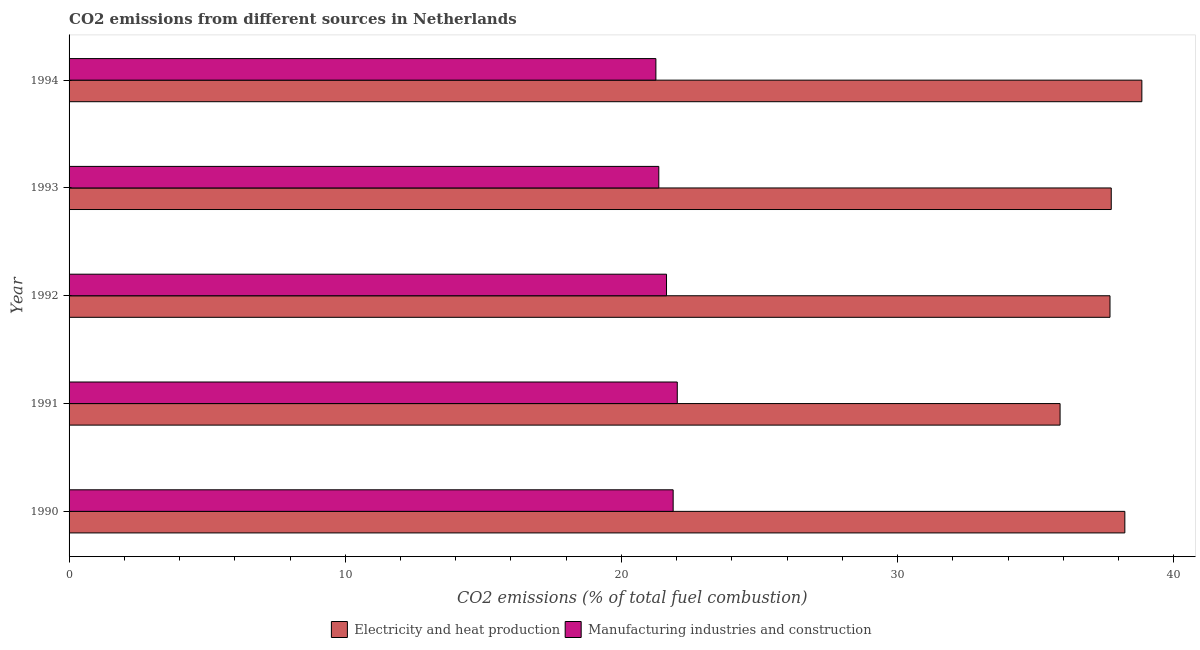How many different coloured bars are there?
Provide a short and direct response. 2. Are the number of bars on each tick of the Y-axis equal?
Give a very brief answer. Yes. What is the label of the 2nd group of bars from the top?
Offer a terse response. 1993. In how many cases, is the number of bars for a given year not equal to the number of legend labels?
Give a very brief answer. 0. What is the co2 emissions due to electricity and heat production in 1992?
Offer a terse response. 37.69. Across all years, what is the maximum co2 emissions due to electricity and heat production?
Make the answer very short. 38.84. Across all years, what is the minimum co2 emissions due to electricity and heat production?
Provide a short and direct response. 35.88. In which year was the co2 emissions due to electricity and heat production minimum?
Your answer should be compact. 1991. What is the total co2 emissions due to manufacturing industries in the graph?
Provide a succinct answer. 108.13. What is the difference between the co2 emissions due to manufacturing industries in 1992 and that in 1993?
Your answer should be very brief. 0.28. What is the difference between the co2 emissions due to manufacturing industries in 1990 and the co2 emissions due to electricity and heat production in 1993?
Your response must be concise. -15.86. What is the average co2 emissions due to electricity and heat production per year?
Provide a short and direct response. 37.68. In the year 1992, what is the difference between the co2 emissions due to manufacturing industries and co2 emissions due to electricity and heat production?
Provide a short and direct response. -16.06. In how many years, is the co2 emissions due to electricity and heat production greater than 36 %?
Your response must be concise. 4. What is the ratio of the co2 emissions due to electricity and heat production in 1990 to that in 1993?
Provide a succinct answer. 1.01. Is the co2 emissions due to electricity and heat production in 1990 less than that in 1992?
Offer a terse response. No. What is the difference between the highest and the second highest co2 emissions due to electricity and heat production?
Make the answer very short. 0.62. What is the difference between the highest and the lowest co2 emissions due to electricity and heat production?
Your answer should be very brief. 2.96. In how many years, is the co2 emissions due to electricity and heat production greater than the average co2 emissions due to electricity and heat production taken over all years?
Provide a short and direct response. 4. Is the sum of the co2 emissions due to manufacturing industries in 1990 and 1994 greater than the maximum co2 emissions due to electricity and heat production across all years?
Make the answer very short. Yes. What does the 2nd bar from the top in 1990 represents?
Make the answer very short. Electricity and heat production. What does the 2nd bar from the bottom in 1990 represents?
Your answer should be compact. Manufacturing industries and construction. How many bars are there?
Your response must be concise. 10. Where does the legend appear in the graph?
Ensure brevity in your answer.  Bottom center. How are the legend labels stacked?
Your response must be concise. Horizontal. What is the title of the graph?
Ensure brevity in your answer.  CO2 emissions from different sources in Netherlands. What is the label or title of the X-axis?
Your answer should be compact. CO2 emissions (% of total fuel combustion). What is the label or title of the Y-axis?
Offer a terse response. Year. What is the CO2 emissions (% of total fuel combustion) of Electricity and heat production in 1990?
Provide a short and direct response. 38.23. What is the CO2 emissions (% of total fuel combustion) in Manufacturing industries and construction in 1990?
Give a very brief answer. 21.87. What is the CO2 emissions (% of total fuel combustion) of Electricity and heat production in 1991?
Provide a succinct answer. 35.88. What is the CO2 emissions (% of total fuel combustion) of Manufacturing industries and construction in 1991?
Provide a succinct answer. 22.02. What is the CO2 emissions (% of total fuel combustion) of Electricity and heat production in 1992?
Provide a succinct answer. 37.69. What is the CO2 emissions (% of total fuel combustion) in Manufacturing industries and construction in 1992?
Provide a succinct answer. 21.63. What is the CO2 emissions (% of total fuel combustion) in Electricity and heat production in 1993?
Offer a very short reply. 37.74. What is the CO2 emissions (% of total fuel combustion) of Manufacturing industries and construction in 1993?
Keep it short and to the point. 21.35. What is the CO2 emissions (% of total fuel combustion) of Electricity and heat production in 1994?
Your answer should be compact. 38.84. What is the CO2 emissions (% of total fuel combustion) of Manufacturing industries and construction in 1994?
Give a very brief answer. 21.25. Across all years, what is the maximum CO2 emissions (% of total fuel combustion) of Electricity and heat production?
Your answer should be very brief. 38.84. Across all years, what is the maximum CO2 emissions (% of total fuel combustion) of Manufacturing industries and construction?
Your answer should be compact. 22.02. Across all years, what is the minimum CO2 emissions (% of total fuel combustion) of Electricity and heat production?
Provide a succinct answer. 35.88. Across all years, what is the minimum CO2 emissions (% of total fuel combustion) of Manufacturing industries and construction?
Make the answer very short. 21.25. What is the total CO2 emissions (% of total fuel combustion) of Electricity and heat production in the graph?
Offer a terse response. 188.39. What is the total CO2 emissions (% of total fuel combustion) in Manufacturing industries and construction in the graph?
Make the answer very short. 108.13. What is the difference between the CO2 emissions (% of total fuel combustion) in Electricity and heat production in 1990 and that in 1991?
Your response must be concise. 2.35. What is the difference between the CO2 emissions (% of total fuel combustion) of Manufacturing industries and construction in 1990 and that in 1991?
Your answer should be very brief. -0.15. What is the difference between the CO2 emissions (% of total fuel combustion) of Electricity and heat production in 1990 and that in 1992?
Your answer should be compact. 0.54. What is the difference between the CO2 emissions (% of total fuel combustion) in Manufacturing industries and construction in 1990 and that in 1992?
Give a very brief answer. 0.24. What is the difference between the CO2 emissions (% of total fuel combustion) of Electricity and heat production in 1990 and that in 1993?
Make the answer very short. 0.49. What is the difference between the CO2 emissions (% of total fuel combustion) in Manufacturing industries and construction in 1990 and that in 1993?
Give a very brief answer. 0.52. What is the difference between the CO2 emissions (% of total fuel combustion) of Electricity and heat production in 1990 and that in 1994?
Offer a very short reply. -0.62. What is the difference between the CO2 emissions (% of total fuel combustion) in Manufacturing industries and construction in 1990 and that in 1994?
Ensure brevity in your answer.  0.63. What is the difference between the CO2 emissions (% of total fuel combustion) in Electricity and heat production in 1991 and that in 1992?
Make the answer very short. -1.81. What is the difference between the CO2 emissions (% of total fuel combustion) of Manufacturing industries and construction in 1991 and that in 1992?
Your answer should be compact. 0.39. What is the difference between the CO2 emissions (% of total fuel combustion) of Electricity and heat production in 1991 and that in 1993?
Provide a short and direct response. -1.85. What is the difference between the CO2 emissions (% of total fuel combustion) in Manufacturing industries and construction in 1991 and that in 1993?
Your response must be concise. 0.67. What is the difference between the CO2 emissions (% of total fuel combustion) in Electricity and heat production in 1991 and that in 1994?
Give a very brief answer. -2.96. What is the difference between the CO2 emissions (% of total fuel combustion) of Manufacturing industries and construction in 1991 and that in 1994?
Make the answer very short. 0.77. What is the difference between the CO2 emissions (% of total fuel combustion) of Electricity and heat production in 1992 and that in 1993?
Your answer should be compact. -0.04. What is the difference between the CO2 emissions (% of total fuel combustion) in Manufacturing industries and construction in 1992 and that in 1993?
Offer a very short reply. 0.28. What is the difference between the CO2 emissions (% of total fuel combustion) of Electricity and heat production in 1992 and that in 1994?
Your answer should be compact. -1.15. What is the difference between the CO2 emissions (% of total fuel combustion) in Manufacturing industries and construction in 1992 and that in 1994?
Your answer should be compact. 0.39. What is the difference between the CO2 emissions (% of total fuel combustion) in Electricity and heat production in 1993 and that in 1994?
Make the answer very short. -1.11. What is the difference between the CO2 emissions (% of total fuel combustion) in Manufacturing industries and construction in 1993 and that in 1994?
Make the answer very short. 0.11. What is the difference between the CO2 emissions (% of total fuel combustion) of Electricity and heat production in 1990 and the CO2 emissions (% of total fuel combustion) of Manufacturing industries and construction in 1991?
Your answer should be very brief. 16.21. What is the difference between the CO2 emissions (% of total fuel combustion) of Electricity and heat production in 1990 and the CO2 emissions (% of total fuel combustion) of Manufacturing industries and construction in 1992?
Provide a succinct answer. 16.6. What is the difference between the CO2 emissions (% of total fuel combustion) in Electricity and heat production in 1990 and the CO2 emissions (% of total fuel combustion) in Manufacturing industries and construction in 1993?
Provide a short and direct response. 16.88. What is the difference between the CO2 emissions (% of total fuel combustion) of Electricity and heat production in 1990 and the CO2 emissions (% of total fuel combustion) of Manufacturing industries and construction in 1994?
Your answer should be compact. 16.98. What is the difference between the CO2 emissions (% of total fuel combustion) in Electricity and heat production in 1991 and the CO2 emissions (% of total fuel combustion) in Manufacturing industries and construction in 1992?
Keep it short and to the point. 14.25. What is the difference between the CO2 emissions (% of total fuel combustion) of Electricity and heat production in 1991 and the CO2 emissions (% of total fuel combustion) of Manufacturing industries and construction in 1993?
Keep it short and to the point. 14.53. What is the difference between the CO2 emissions (% of total fuel combustion) of Electricity and heat production in 1991 and the CO2 emissions (% of total fuel combustion) of Manufacturing industries and construction in 1994?
Provide a short and direct response. 14.64. What is the difference between the CO2 emissions (% of total fuel combustion) of Electricity and heat production in 1992 and the CO2 emissions (% of total fuel combustion) of Manufacturing industries and construction in 1993?
Ensure brevity in your answer.  16.34. What is the difference between the CO2 emissions (% of total fuel combustion) in Electricity and heat production in 1992 and the CO2 emissions (% of total fuel combustion) in Manufacturing industries and construction in 1994?
Ensure brevity in your answer.  16.44. What is the difference between the CO2 emissions (% of total fuel combustion) of Electricity and heat production in 1993 and the CO2 emissions (% of total fuel combustion) of Manufacturing industries and construction in 1994?
Offer a very short reply. 16.49. What is the average CO2 emissions (% of total fuel combustion) of Electricity and heat production per year?
Your answer should be very brief. 37.68. What is the average CO2 emissions (% of total fuel combustion) of Manufacturing industries and construction per year?
Your answer should be very brief. 21.63. In the year 1990, what is the difference between the CO2 emissions (% of total fuel combustion) in Electricity and heat production and CO2 emissions (% of total fuel combustion) in Manufacturing industries and construction?
Ensure brevity in your answer.  16.36. In the year 1991, what is the difference between the CO2 emissions (% of total fuel combustion) of Electricity and heat production and CO2 emissions (% of total fuel combustion) of Manufacturing industries and construction?
Offer a terse response. 13.86. In the year 1992, what is the difference between the CO2 emissions (% of total fuel combustion) of Electricity and heat production and CO2 emissions (% of total fuel combustion) of Manufacturing industries and construction?
Ensure brevity in your answer.  16.06. In the year 1993, what is the difference between the CO2 emissions (% of total fuel combustion) of Electricity and heat production and CO2 emissions (% of total fuel combustion) of Manufacturing industries and construction?
Give a very brief answer. 16.38. In the year 1994, what is the difference between the CO2 emissions (% of total fuel combustion) of Electricity and heat production and CO2 emissions (% of total fuel combustion) of Manufacturing industries and construction?
Offer a terse response. 17.6. What is the ratio of the CO2 emissions (% of total fuel combustion) in Electricity and heat production in 1990 to that in 1991?
Ensure brevity in your answer.  1.07. What is the ratio of the CO2 emissions (% of total fuel combustion) of Manufacturing industries and construction in 1990 to that in 1991?
Provide a short and direct response. 0.99. What is the ratio of the CO2 emissions (% of total fuel combustion) in Electricity and heat production in 1990 to that in 1992?
Keep it short and to the point. 1.01. What is the ratio of the CO2 emissions (% of total fuel combustion) in Manufacturing industries and construction in 1990 to that in 1992?
Your answer should be very brief. 1.01. What is the ratio of the CO2 emissions (% of total fuel combustion) of Manufacturing industries and construction in 1990 to that in 1993?
Offer a terse response. 1.02. What is the ratio of the CO2 emissions (% of total fuel combustion) in Electricity and heat production in 1990 to that in 1994?
Keep it short and to the point. 0.98. What is the ratio of the CO2 emissions (% of total fuel combustion) of Manufacturing industries and construction in 1990 to that in 1994?
Your answer should be very brief. 1.03. What is the ratio of the CO2 emissions (% of total fuel combustion) of Manufacturing industries and construction in 1991 to that in 1992?
Provide a short and direct response. 1.02. What is the ratio of the CO2 emissions (% of total fuel combustion) of Electricity and heat production in 1991 to that in 1993?
Give a very brief answer. 0.95. What is the ratio of the CO2 emissions (% of total fuel combustion) of Manufacturing industries and construction in 1991 to that in 1993?
Provide a succinct answer. 1.03. What is the ratio of the CO2 emissions (% of total fuel combustion) of Electricity and heat production in 1991 to that in 1994?
Provide a short and direct response. 0.92. What is the ratio of the CO2 emissions (% of total fuel combustion) of Manufacturing industries and construction in 1991 to that in 1994?
Give a very brief answer. 1.04. What is the ratio of the CO2 emissions (% of total fuel combustion) of Manufacturing industries and construction in 1992 to that in 1993?
Provide a succinct answer. 1.01. What is the ratio of the CO2 emissions (% of total fuel combustion) of Electricity and heat production in 1992 to that in 1994?
Your answer should be compact. 0.97. What is the ratio of the CO2 emissions (% of total fuel combustion) in Manufacturing industries and construction in 1992 to that in 1994?
Provide a short and direct response. 1.02. What is the ratio of the CO2 emissions (% of total fuel combustion) in Electricity and heat production in 1993 to that in 1994?
Your answer should be very brief. 0.97. What is the difference between the highest and the second highest CO2 emissions (% of total fuel combustion) in Electricity and heat production?
Your response must be concise. 0.62. What is the difference between the highest and the second highest CO2 emissions (% of total fuel combustion) in Manufacturing industries and construction?
Offer a terse response. 0.15. What is the difference between the highest and the lowest CO2 emissions (% of total fuel combustion) of Electricity and heat production?
Give a very brief answer. 2.96. What is the difference between the highest and the lowest CO2 emissions (% of total fuel combustion) in Manufacturing industries and construction?
Your response must be concise. 0.77. 